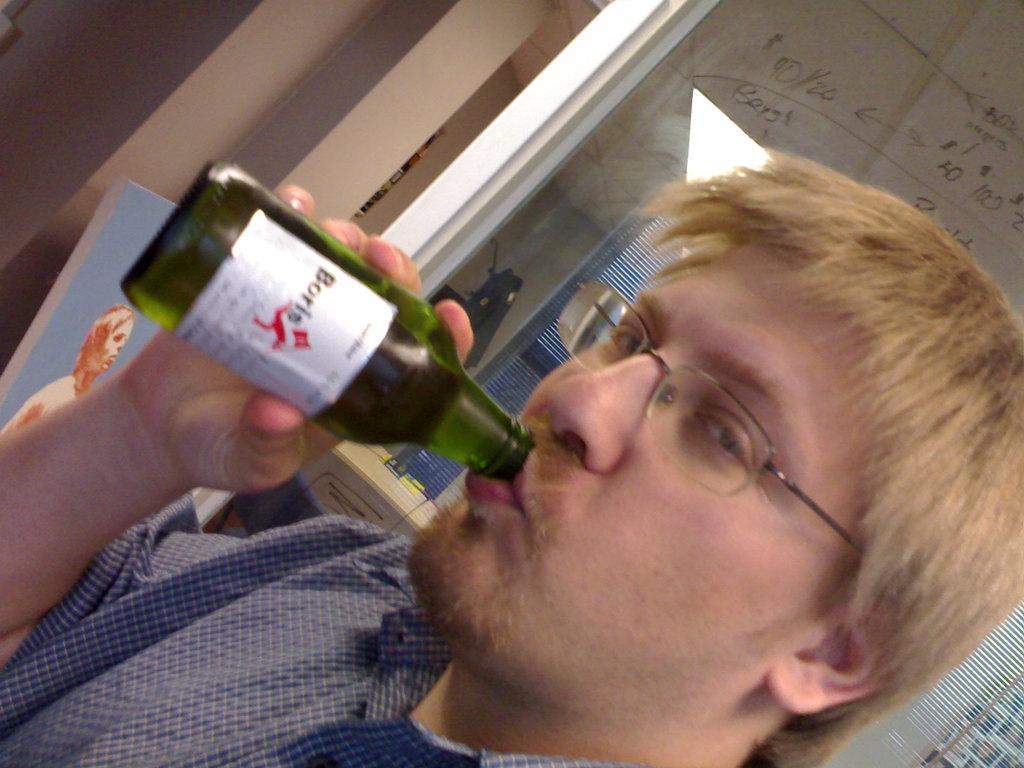Can you describe this image briefly? One man is drinking and standing in the picture wearing glasses behind there is a glass on which some text is written and left corner one photo is present. 